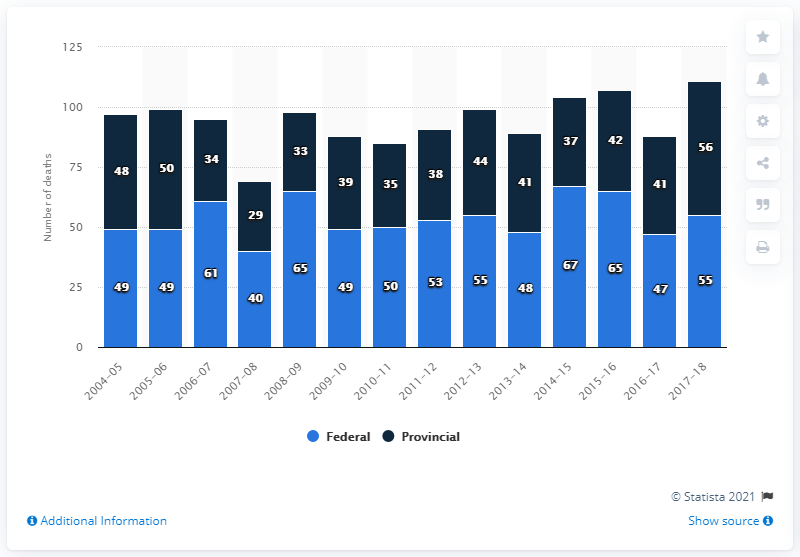Specify some key components in this picture. In the fiscal year of 2018, there were 55 inmates who died in federal prisons in Canada. 